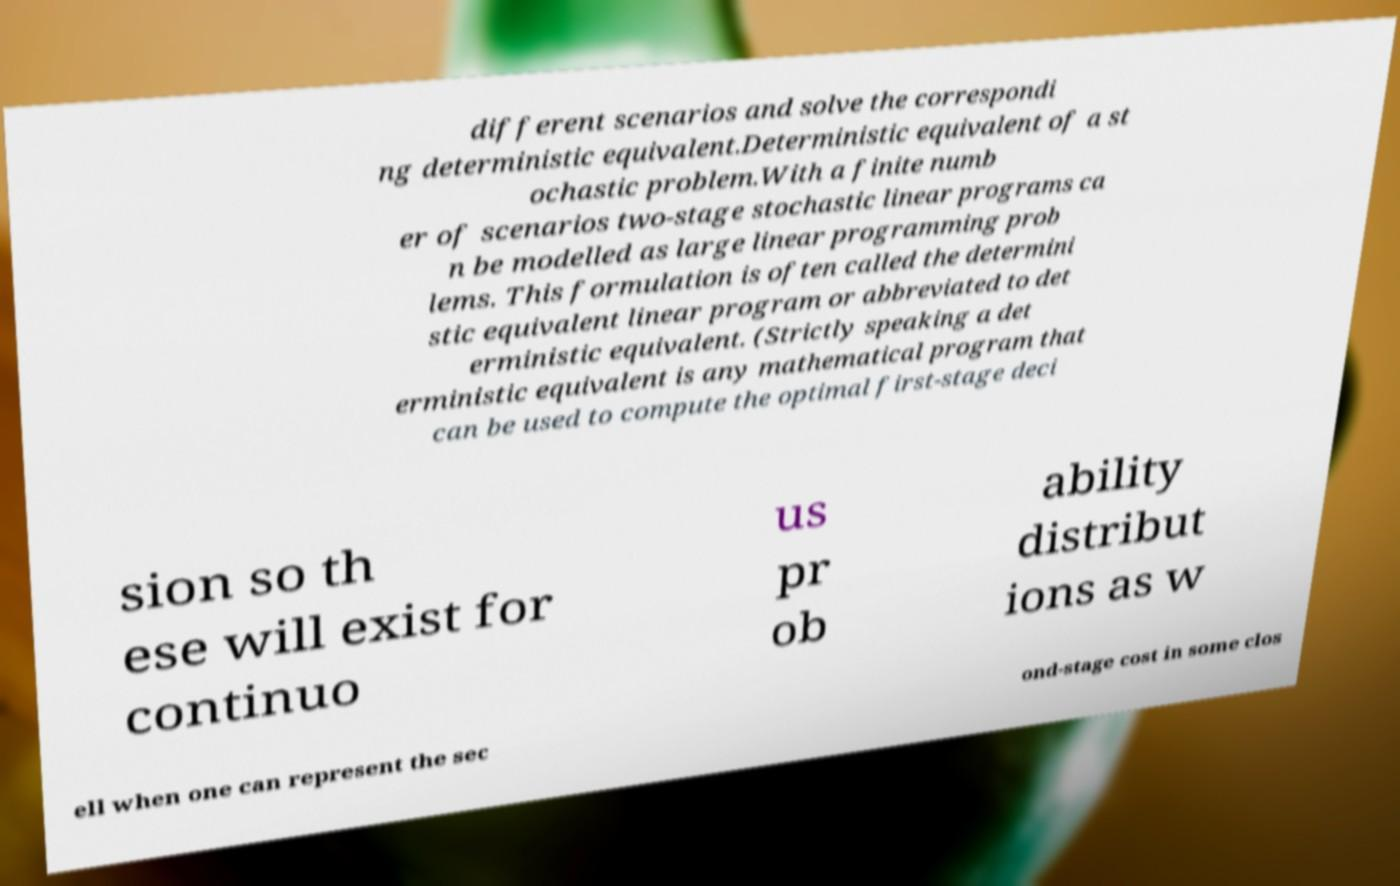Please read and relay the text visible in this image. What does it say? different scenarios and solve the correspondi ng deterministic equivalent.Deterministic equivalent of a st ochastic problem.With a finite numb er of scenarios two-stage stochastic linear programs ca n be modelled as large linear programming prob lems. This formulation is often called the determini stic equivalent linear program or abbreviated to det erministic equivalent. (Strictly speaking a det erministic equivalent is any mathematical program that can be used to compute the optimal first-stage deci sion so th ese will exist for continuo us pr ob ability distribut ions as w ell when one can represent the sec ond-stage cost in some clos 